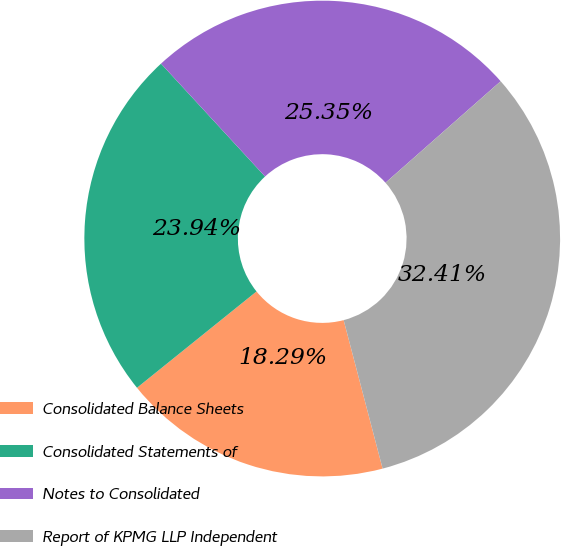Convert chart to OTSL. <chart><loc_0><loc_0><loc_500><loc_500><pie_chart><fcel>Consolidated Balance Sheets<fcel>Consolidated Statements of<fcel>Notes to Consolidated<fcel>Report of KPMG LLP Independent<nl><fcel>18.29%<fcel>23.94%<fcel>25.35%<fcel>32.41%<nl></chart> 